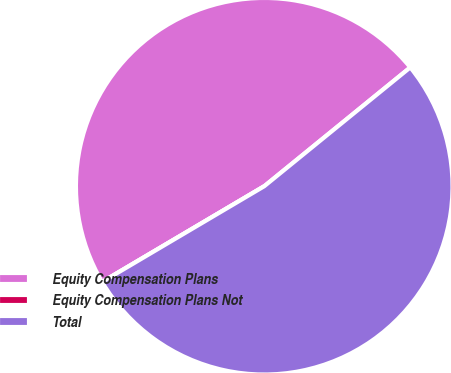Convert chart to OTSL. <chart><loc_0><loc_0><loc_500><loc_500><pie_chart><fcel>Equity Compensation Plans<fcel>Equity Compensation Plans Not<fcel>Total<nl><fcel>47.62%<fcel>0.0%<fcel>52.38%<nl></chart> 